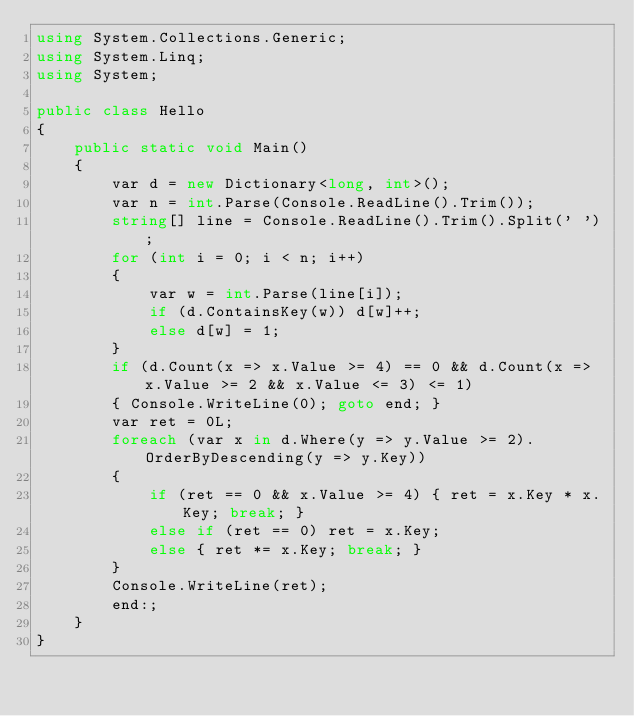Convert code to text. <code><loc_0><loc_0><loc_500><loc_500><_C#_>using System.Collections.Generic;
using System.Linq;
using System;

public class Hello
{
    public static void Main()
    {
        var d = new Dictionary<long, int>();
        var n = int.Parse(Console.ReadLine().Trim());
        string[] line = Console.ReadLine().Trim().Split(' ');
        for (int i = 0; i < n; i++)
        {
            var w = int.Parse(line[i]);
            if (d.ContainsKey(w)) d[w]++;
            else d[w] = 1;
        }
        if (d.Count(x => x.Value >= 4) == 0 && d.Count(x => x.Value >= 2 && x.Value <= 3) <= 1)
        { Console.WriteLine(0); goto end; }
        var ret = 0L;
        foreach (var x in d.Where(y => y.Value >= 2).OrderByDescending(y => y.Key))
        {
            if (ret == 0 && x.Value >= 4) { ret = x.Key * x.Key; break; }
            else if (ret == 0) ret = x.Key;
            else { ret *= x.Key; break; }
        }
        Console.WriteLine(ret);
        end:;
    }
}

</code> 